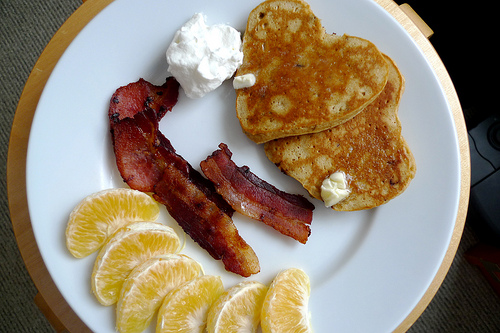<image>
Can you confirm if the bacon is on the plate? Yes. Looking at the image, I can see the bacon is positioned on top of the plate, with the plate providing support. 